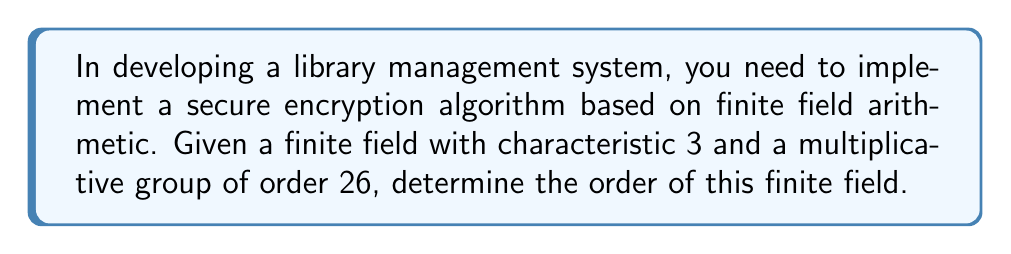Can you solve this math problem? Let's approach this step-by-step:

1) In a finite field $\mathbb{F}_q$, where $q$ is the order of the field, we know that $q = p^n$, where:
   - $p$ is the characteristic of the field
   - $n$ is a positive integer

2) We're given that the characteristic is 3, so $p = 3$

3) The multiplicative group of a finite field $\mathbb{F}_q$ has order $q - 1$

4) We're told that the multiplicative group has order 26, so:

   $q - 1 = 26$
   $q = 27$

5) Now, we need to verify if this satisfies the form $q = p^n$:

   $27 = 3^3$

6) Indeed, $27 = 3^3$, which confirms our result and gives us $n = 3$

Therefore, the order of the finite field is $3^3 = 27$.
Answer: $27$ 